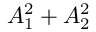<formula> <loc_0><loc_0><loc_500><loc_500>A _ { 1 } ^ { 2 } + A _ { 2 } ^ { 2 }</formula> 